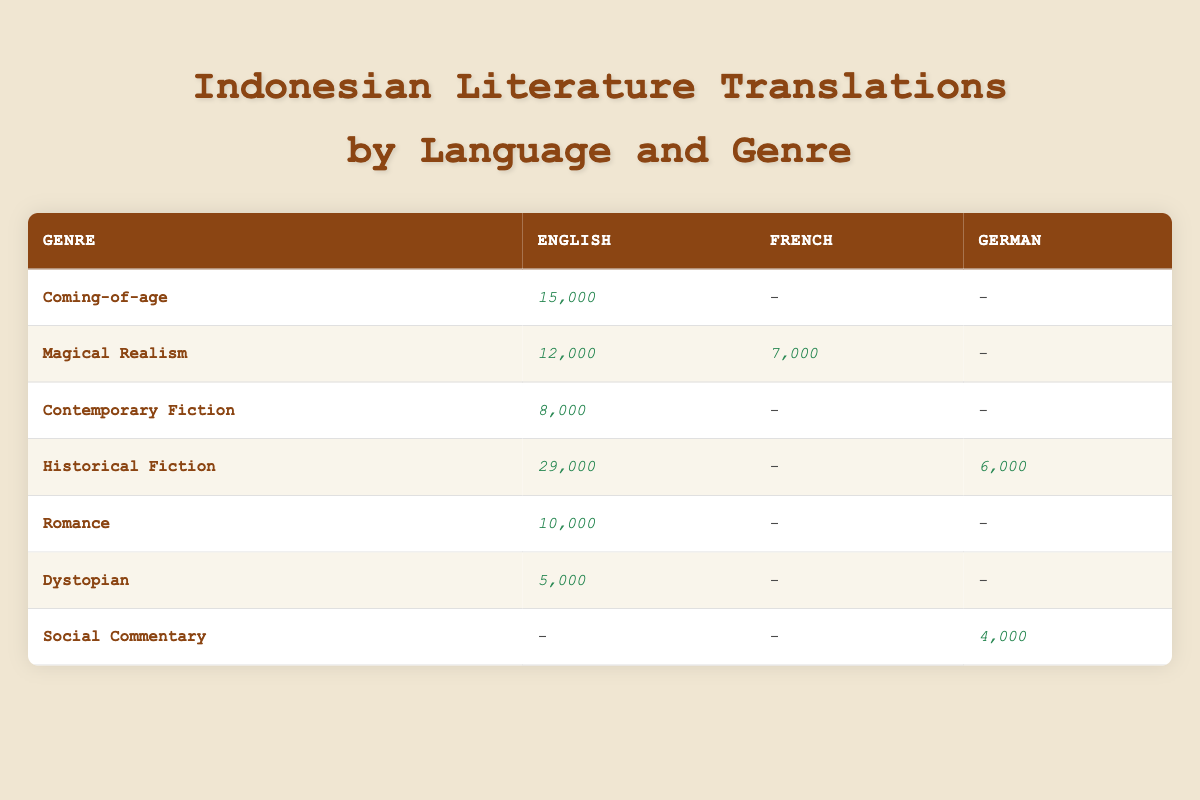What's the total sales for the Historical Fiction genre in English translations? To find the total sales for Historical Fiction in English, I look at the row for Historical Fiction in the English column. The sales figure is 29,000.
Answer: 29,000 How many different genres are represented in English translations? Looking at the table, the genres listed for English translations are Coming-of-age, Magical Realism, Contemporary Fiction, Historical Fiction, Romance, Dystopian, and Social Commentary. There are 7 distinct genres.
Answer: 7 Which genre has the highest total sales when combining all translated languages? To calculate this, I sum the sales for each genre across all columns. The totals are: Coming-of-age (15,000), Magical Realism (19,000), Contemporary Fiction (8,000), Historical Fiction (35,000), Romance (10,000), Dystopian (5,000), and Social Commentary (4,000). The highest total is for Historical Fiction with 35,000.
Answer: Historical Fiction Are there any translations for Social Commentary in English? Referring to the table, Social Commentary has no sales listed in the English column, indicating that there are no translations in this language.
Answer: No What is the average sales for Magical Realism translations across all languages? The sales for Magical Realism are as follows: English (12,000) and French (7,000). To find the average, I sum these values (12,000 + 7,000 = 19,000) and divide by the number of translations (2), which gives an average of 19,000/2 = 9,500.
Answer: 9,500 